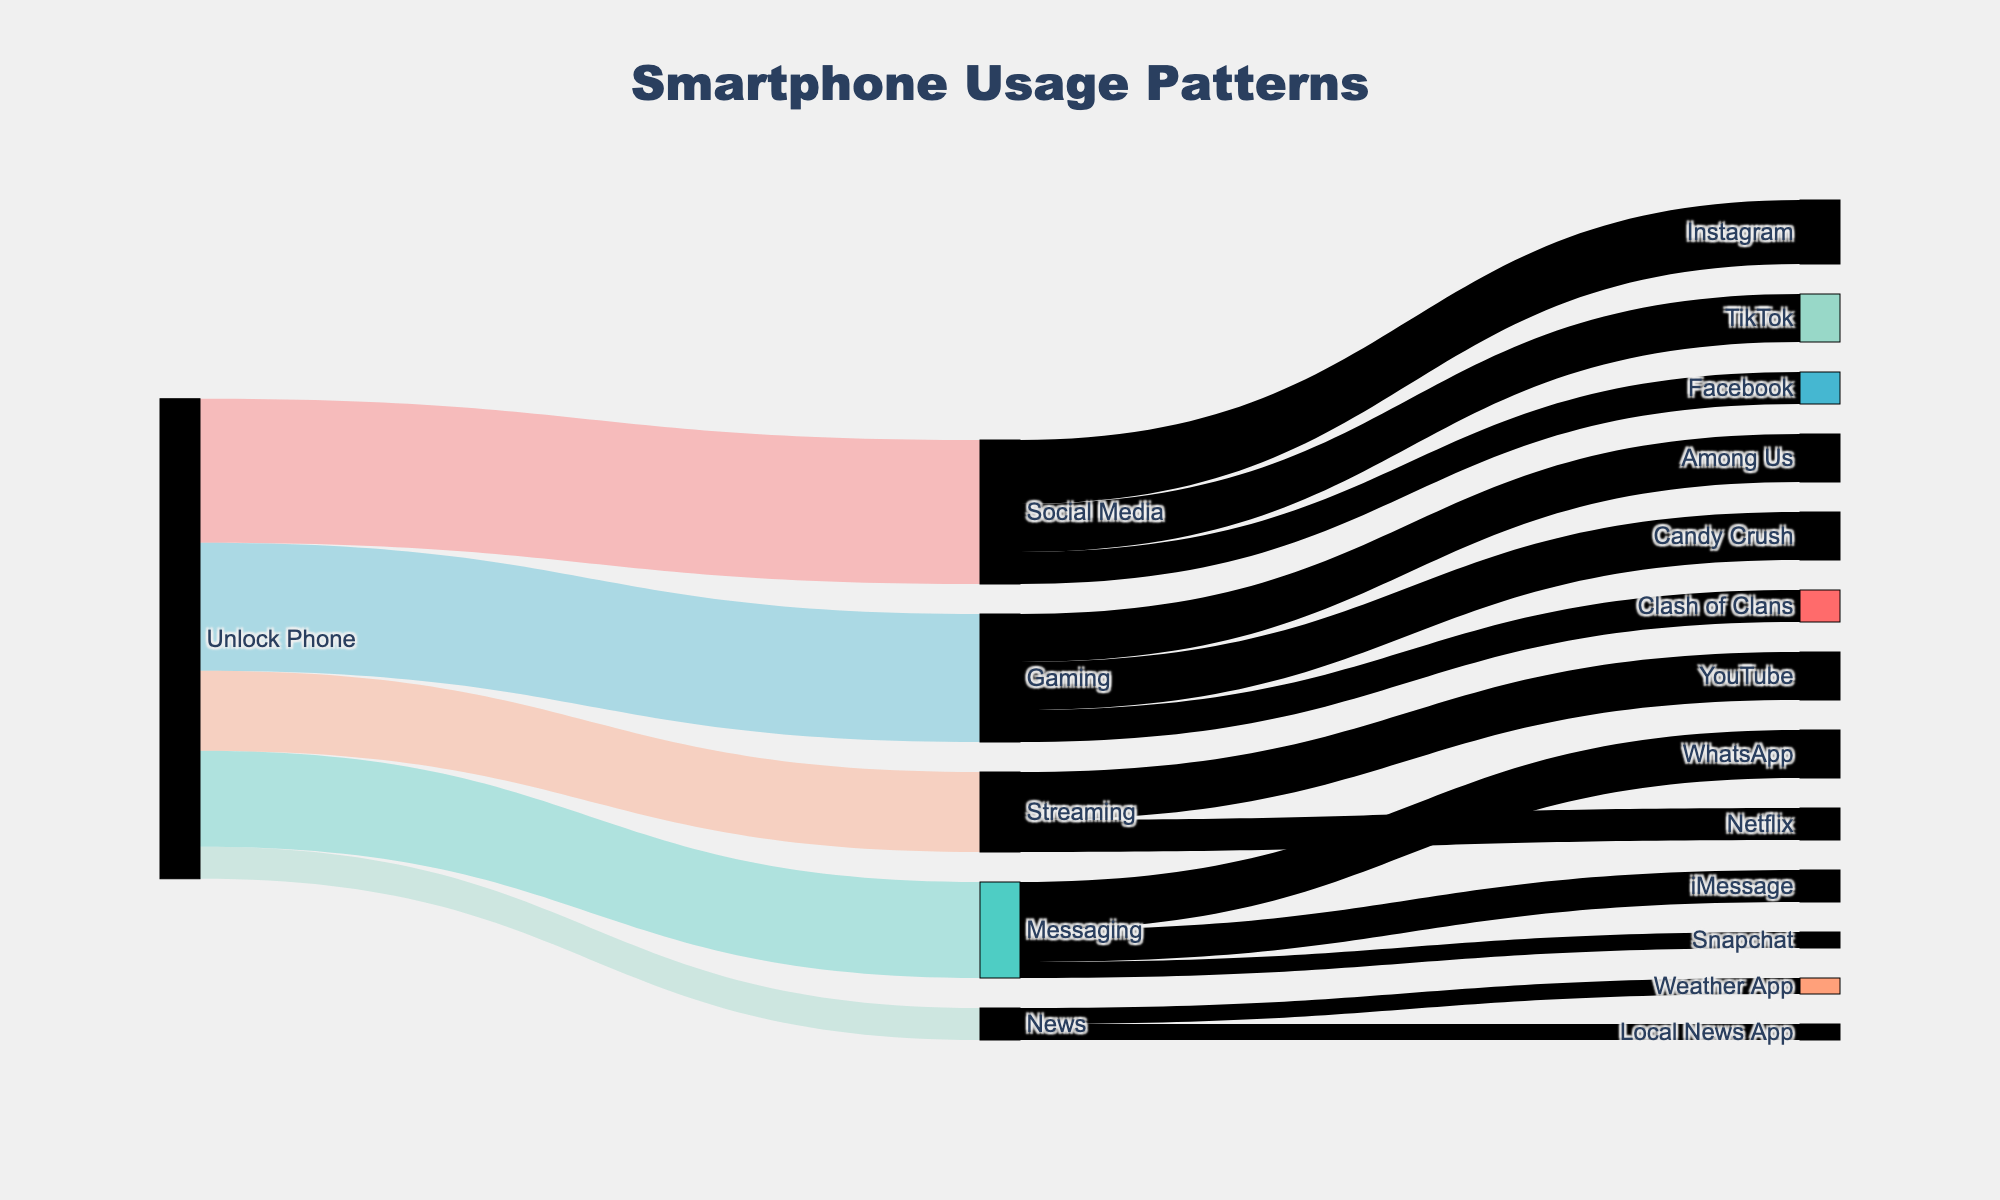What's the total time spent on Social Media apps? First, identify the flows going from 'Social Media'. The target apps are Instagram (20 minutes), TikTok (15 minutes), and Facebook (10 minutes). Summing these values: 20 + 15 + 10 = 45 minutes.
Answer: 45 minutes Which activity takes the largest share of time after unlocking the phone? Compare the values from 'Unlock Phone' to different activities. Social Media has 45 minutes, Messaging has 30 minutes, Gaming has 40 minutes, Streaming has 25 minutes, and News has 10 minutes. Social Media has the largest share with 45 minutes.
Answer: Social Media How much more time is spent on Gaming compared to News? Find the values of 'Gaming' and 'News' from 'Unlock Phone'. Gaming is 40 minutes; News is 10 minutes. The difference is 40 - 10 = 30 minutes.
Answer: 30 minutes Which specific app within 'Messaging' is used the most? Check the flows from 'Messaging'. WhatsApp has 15 minutes, iMessage has 10 minutes, and Snapchat has 5 minutes. WhatsApp is used the most with 15 minutes.
Answer: WhatsApp What is the combined time spent on Streaming activities? Identify the flows from 'Streaming'. The target apps are YouTube (15 minutes) and Netflix (10 minutes). Summing these values: 15 + 10 = 25 minutes.
Answer: 25 minutes Is more time spent on Messaging or Streaming? Compare the values from 'Unlock Phone' to 'Messaging' and 'Streaming'. Messaging has 30 minutes, while Streaming has 25 minutes. More time is spent on Messaging.
Answer: Messaging What is the least used specific app in the diagram? Compare the flow values for all specific apps: Facebook (10), Snapchat (5), Weather App (5), Local News App (5), Candy Crush (15), Clash of Clans (10), Among Us (15), Instagram (20), TikTok (15), WhatsApp (15), iMessage (10), YouTube (15), Netflix (10). The apps with the least usage (5 minutes) are Snapchat, Weather App, and Local News App.
Answer: Snapchat, Weather App, and Local News App How does the time spent on Instagram compare to TikTok? Check the values from 'Social Media'. Instagram has 20 minutes, while TikTok has 15 minutes. More time is spent on Instagram.
Answer: Instagram What's the total time spent on activities other than Social Media? Calculate the sum of flows from 'Unlock Phone' to all activities excluding Social Media (45 minutes): Messaging (30 minutes) + Gaming (40 minutes) + Streaming (25 minutes) + News (10 minutes). Sum: 30 + 40 + 25 + 10 = 105 minutes.
Answer: 105 minutes 